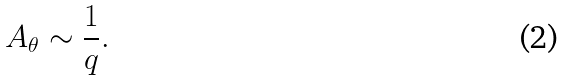<formula> <loc_0><loc_0><loc_500><loc_500>A _ { \theta } \sim \frac { 1 } { q } .</formula> 